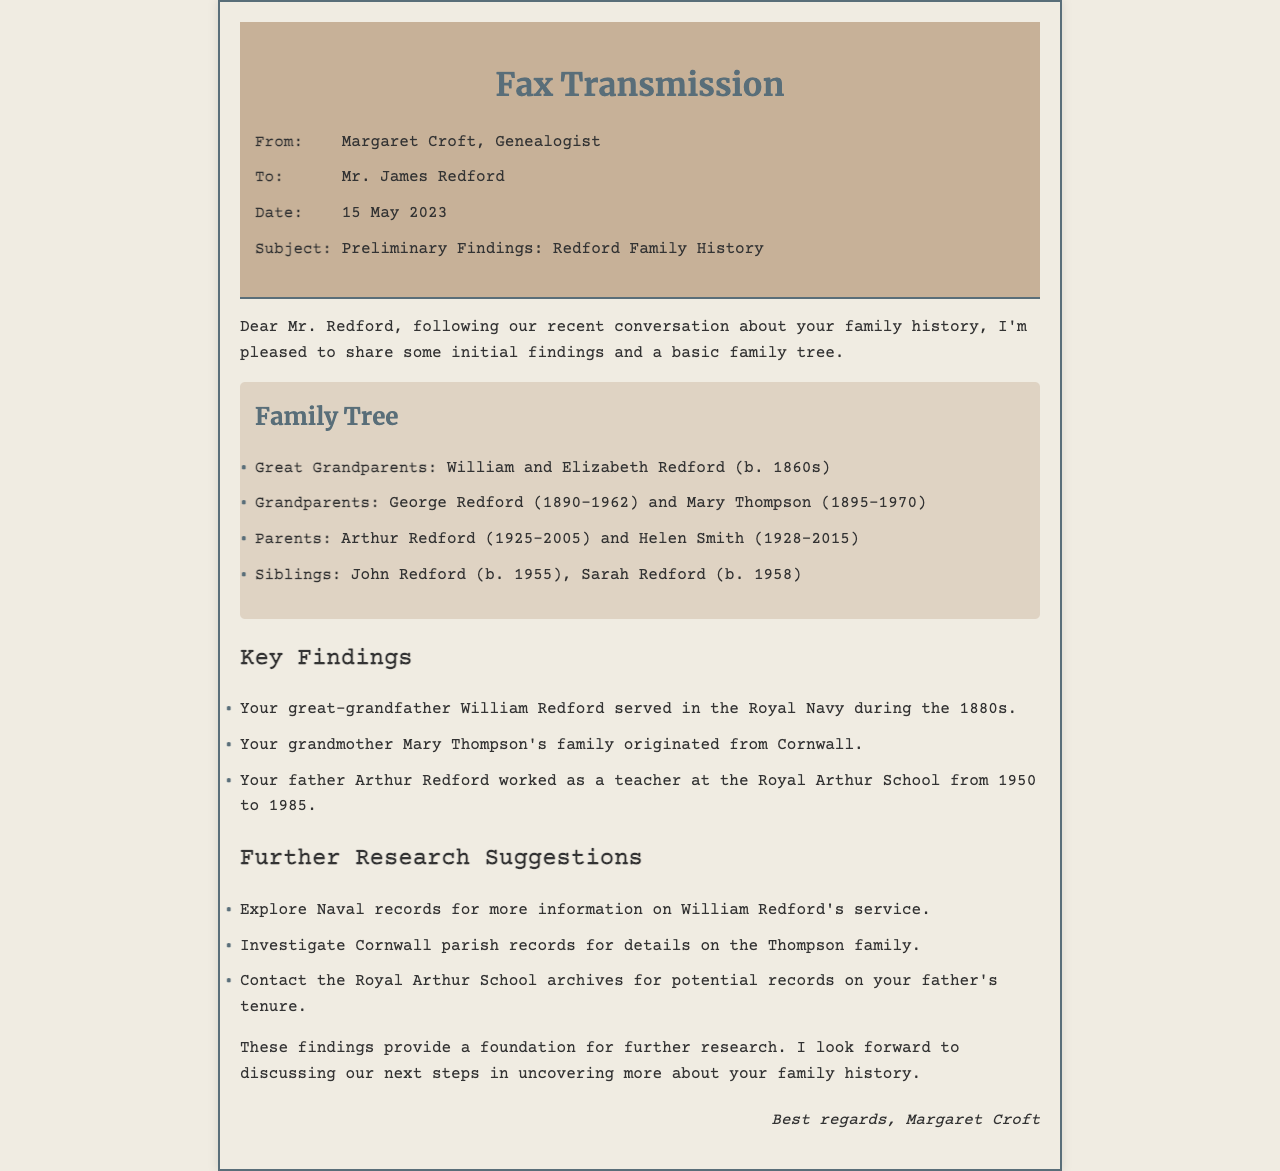what is the sender's name? The sender's name is found in the fax header.
Answer: Margaret Croft what is the recipient's name? The recipient's name is stated in the 'To' section of the fax details.
Answer: Mr. James Redford when was the fax sent? The date of the fax transmission is listed in the fax details.
Answer: 15 May 2023 who are the great grandparents? The names of the great grandparents are mentioned in the family tree section.
Answer: William and Elizabeth Redford what was Arthur Redford's profession? Arthur Redford's occupation is detailed in the key findings section.
Answer: teacher which military branch did William Redford serve in? Information about William Redford's service is mentioned in the key findings section.
Answer: Royal Navy what is one suggestion for further research? Suggestions for further research are listed towards the end of the document.
Answer: Explore Naval records how long did Arthur Redford work at the Royal Arthur School? The duration of Arthur Redford's tenure is stated in the key findings section.
Answer: 35 years 